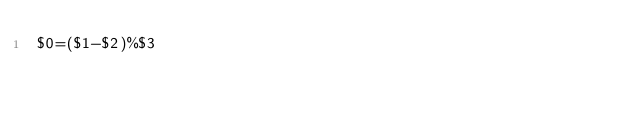Convert code to text. <code><loc_0><loc_0><loc_500><loc_500><_Awk_>$0=($1-$2)%$3</code> 